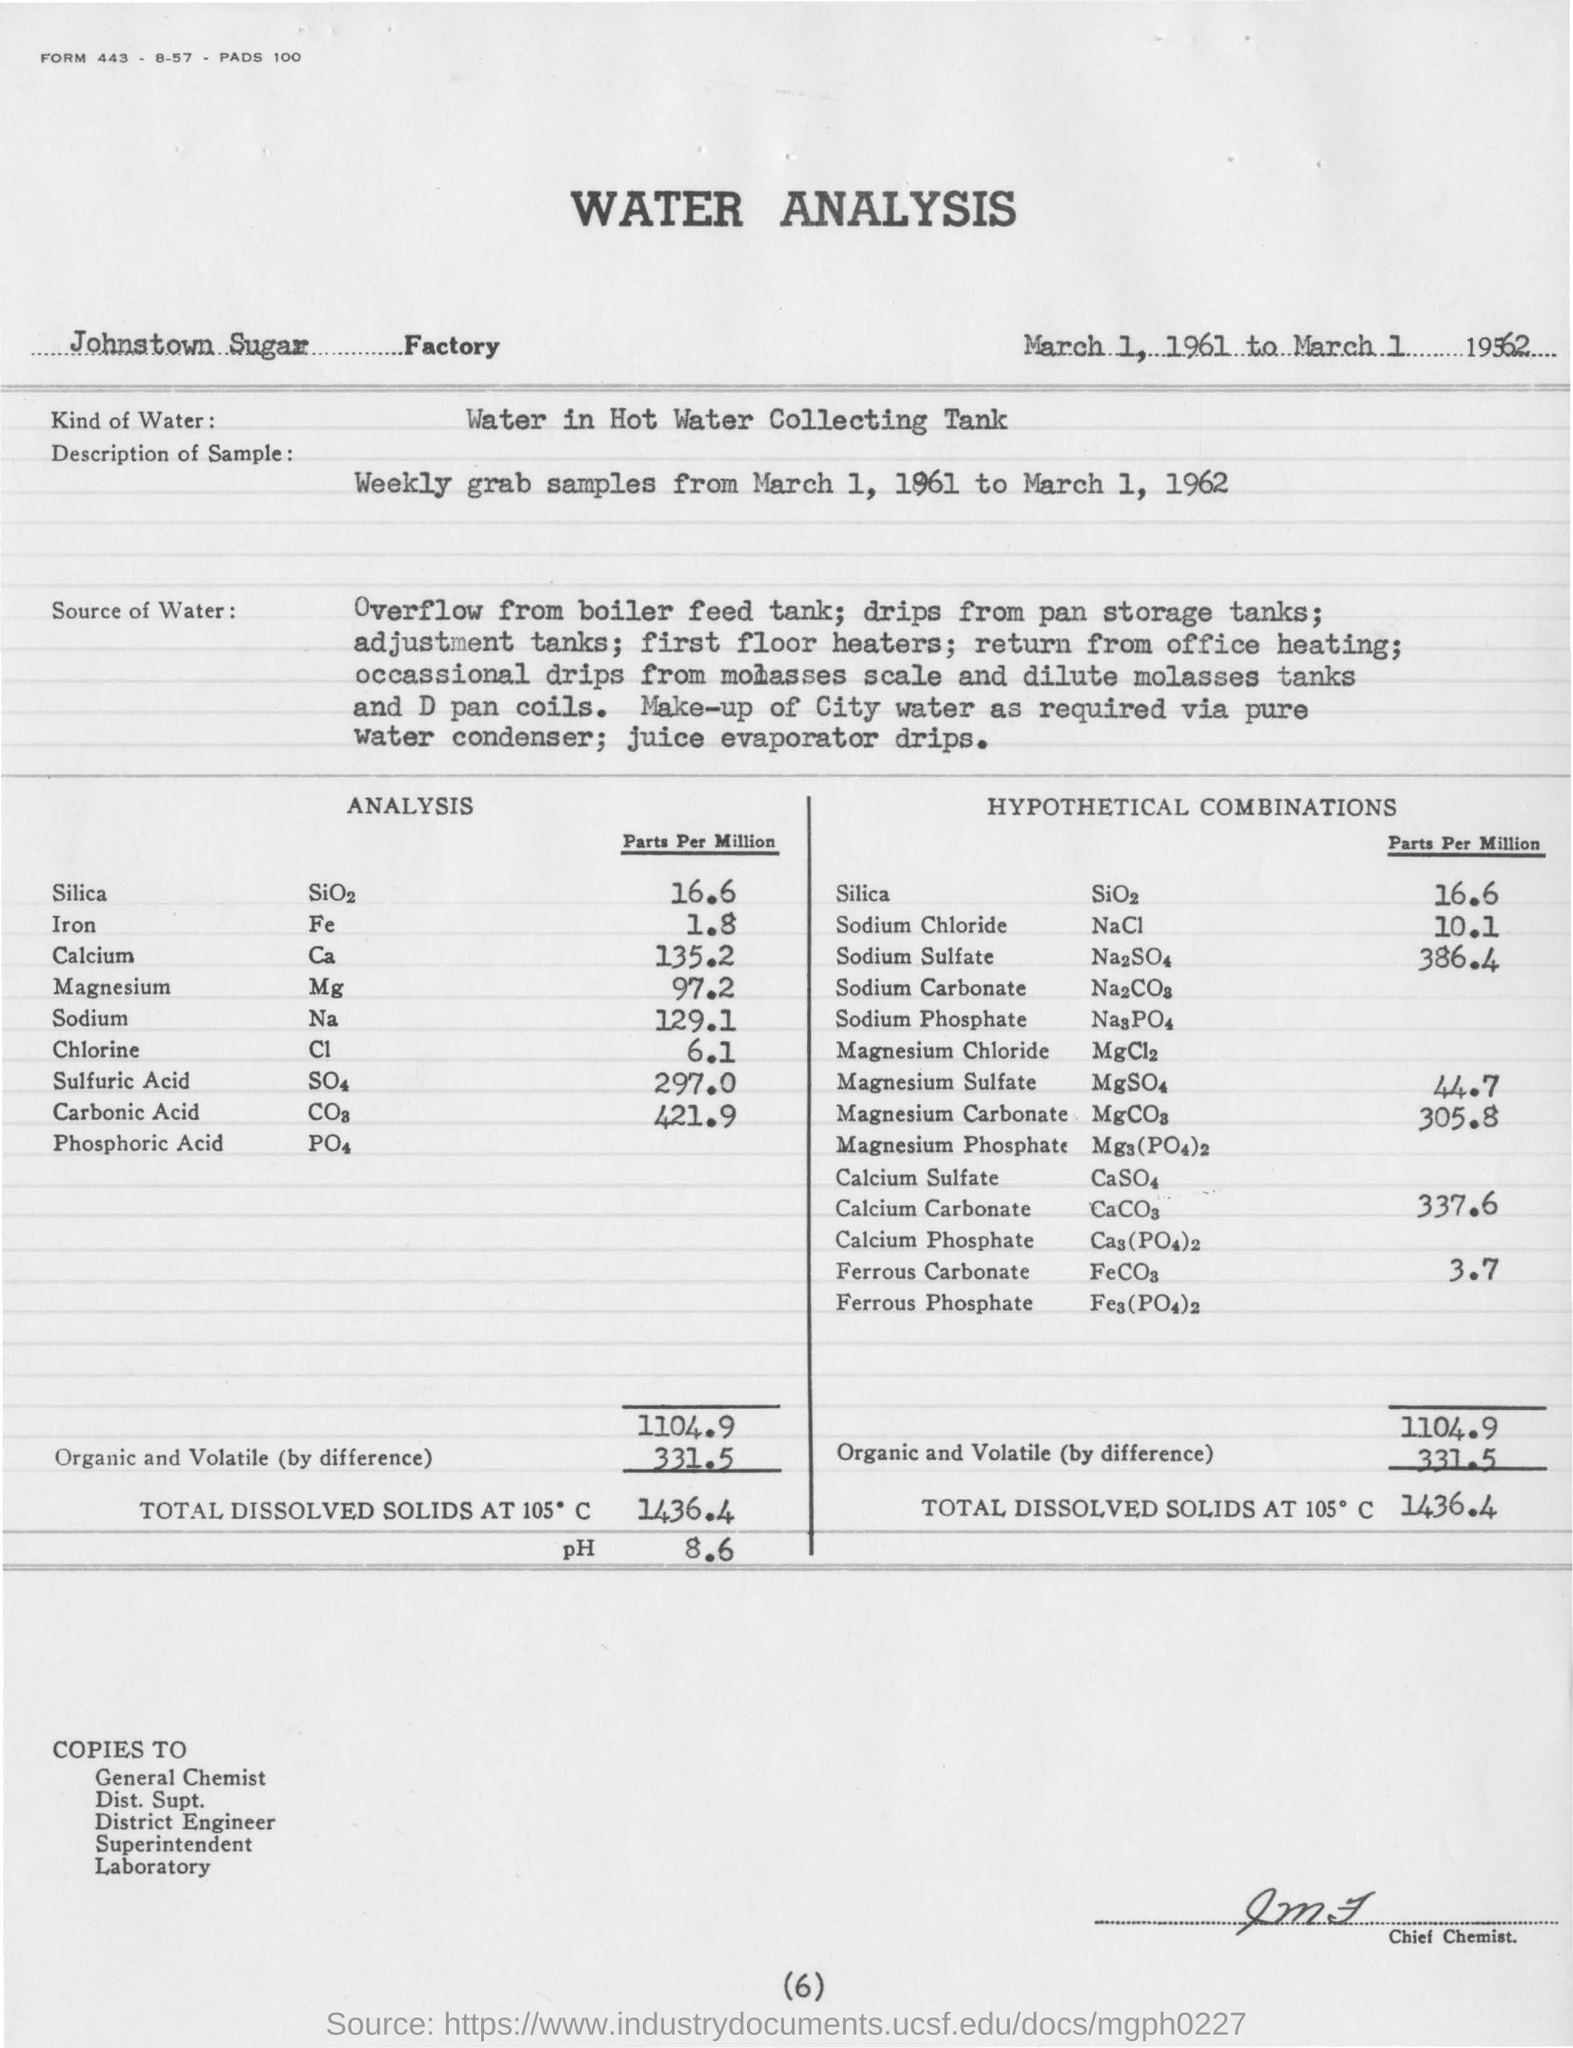List a handful of essential elements in this visual. The analysis report mentions the type of water that is stored in the hot water collecting tank. The report mentions a pH value of 8.6. 